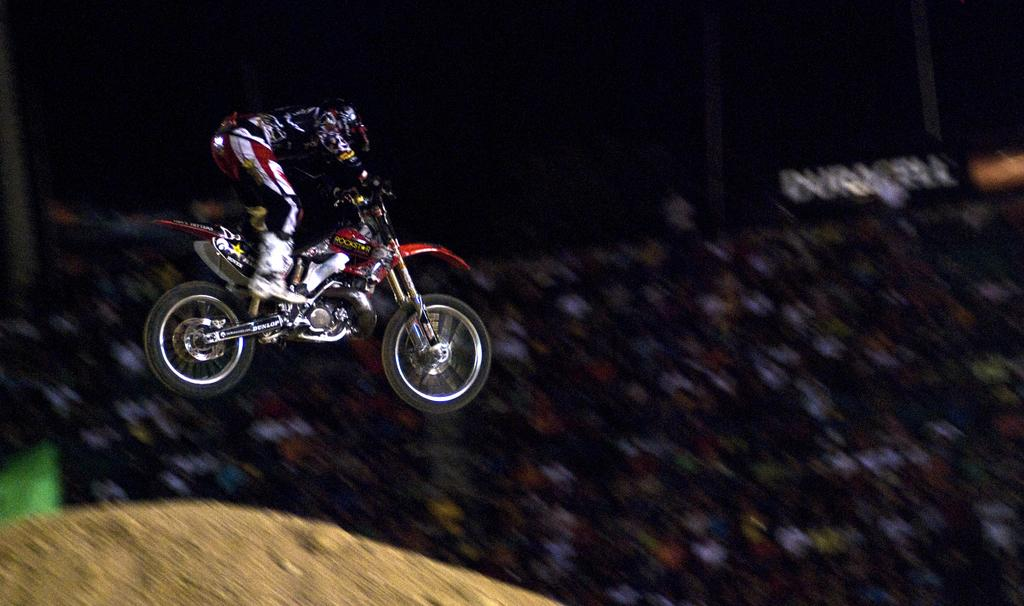What is the main subject of the image? There is a person riding a bike in the image. Can you describe the activity of the person in the image? The person is riding a bike. What can be seen in the background of the image? In the background of the image, there are people sitting. How many knives are being used by the person riding the bike in the image? There are no knives present in the image. What type of footwear is the person riding the bike wearing in the image? The image does not show the person's footwear. 